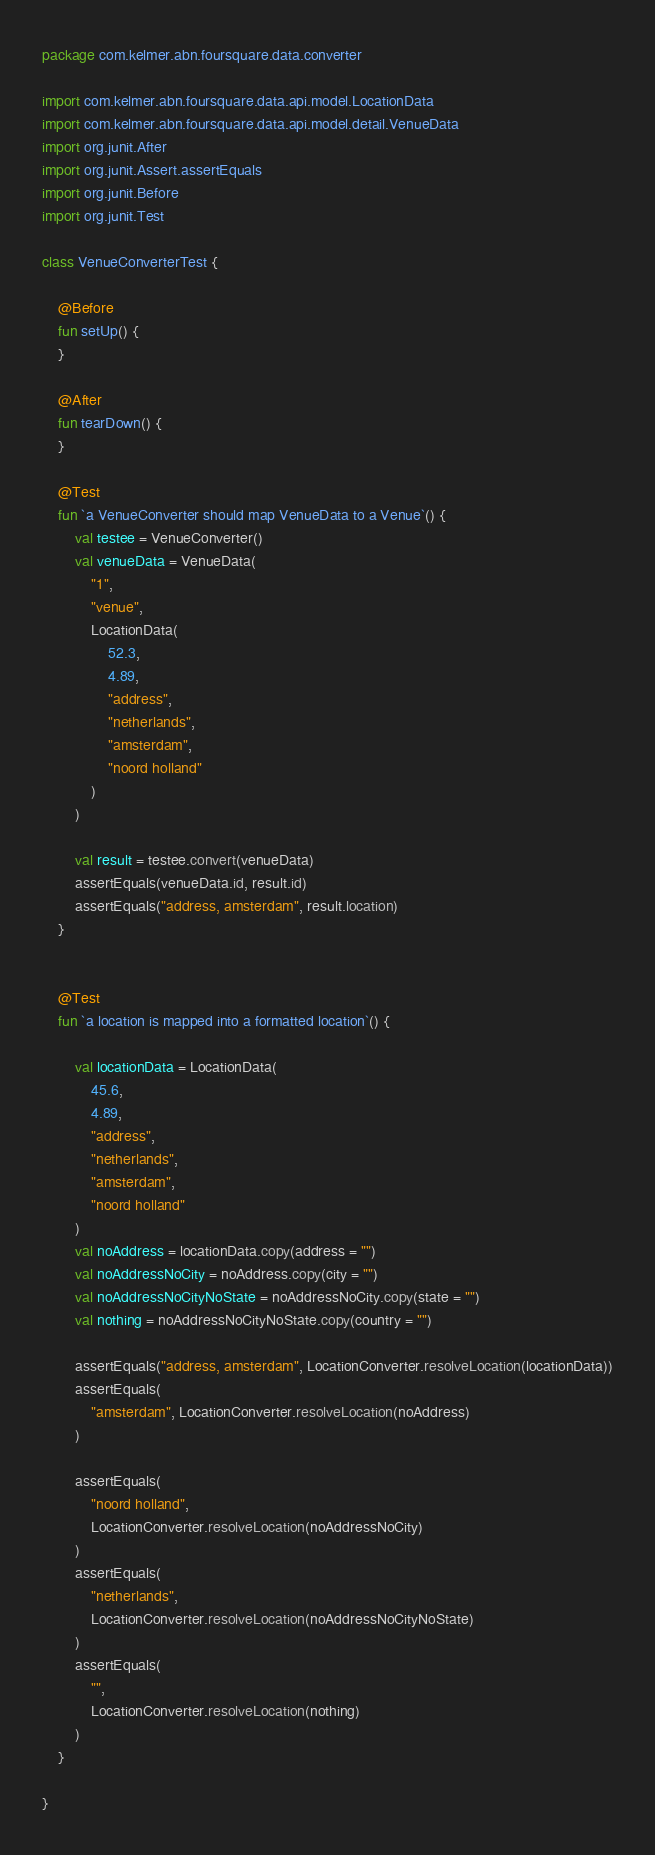Convert code to text. <code><loc_0><loc_0><loc_500><loc_500><_Kotlin_>package com.kelmer.abn.foursquare.data.converter

import com.kelmer.abn.foursquare.data.api.model.LocationData
import com.kelmer.abn.foursquare.data.api.model.detail.VenueData
import org.junit.After
import org.junit.Assert.assertEquals
import org.junit.Before
import org.junit.Test

class VenueConverterTest {

    @Before
    fun setUp() {
    }

    @After
    fun tearDown() {
    }

    @Test
    fun `a VenueConverter should map VenueData to a Venue`() {
        val testee = VenueConverter()
        val venueData = VenueData(
            "1",
            "venue",
            LocationData(
                52.3,
                4.89,
                "address",
                "netherlands",
                "amsterdam",
                "noord holland"
            )
        )

        val result = testee.convert(venueData)
        assertEquals(venueData.id, result.id)
        assertEquals("address, amsterdam", result.location)
    }


    @Test
    fun `a location is mapped into a formatted location`() {

        val locationData = LocationData(
            45.6,
            4.89,
            "address",
            "netherlands",
            "amsterdam",
            "noord holland"
        )
        val noAddress = locationData.copy(address = "")
        val noAddressNoCity = noAddress.copy(city = "")
        val noAddressNoCityNoState = noAddressNoCity.copy(state = "")
        val nothing = noAddressNoCityNoState.copy(country = "")

        assertEquals("address, amsterdam", LocationConverter.resolveLocation(locationData))
        assertEquals(
            "amsterdam", LocationConverter.resolveLocation(noAddress)
        )

        assertEquals(
            "noord holland",
            LocationConverter.resolveLocation(noAddressNoCity)
        )
        assertEquals(
            "netherlands",
            LocationConverter.resolveLocation(noAddressNoCityNoState)
        )
        assertEquals(
            "",
            LocationConverter.resolveLocation(nothing)
        )
    }

}</code> 